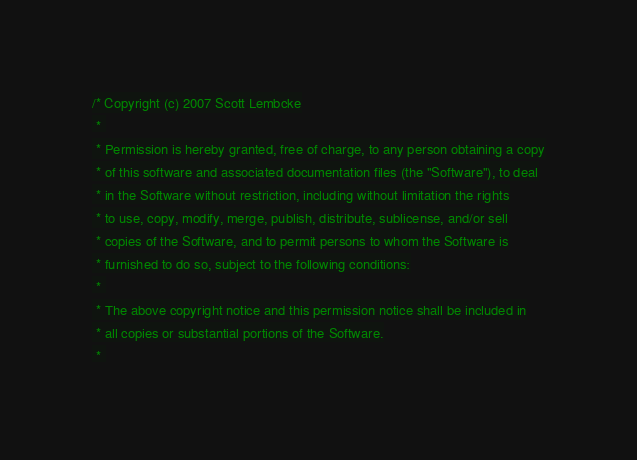Convert code to text. <code><loc_0><loc_0><loc_500><loc_500><_C_>/* Copyright (c) 2007 Scott Lembcke
 * 
 * Permission is hereby granted, free of charge, to any person obtaining a copy
 * of this software and associated documentation files (the "Software"), to deal
 * in the Software without restriction, including without limitation the rights
 * to use, copy, modify, merge, publish, distribute, sublicense, and/or sell
 * copies of the Software, and to permit persons to whom the Software is
 * furnished to do so, subject to the following conditions:
 * 
 * The above copyright notice and this permission notice shall be included in
 * all copies or substantial portions of the Software.
 * </code> 